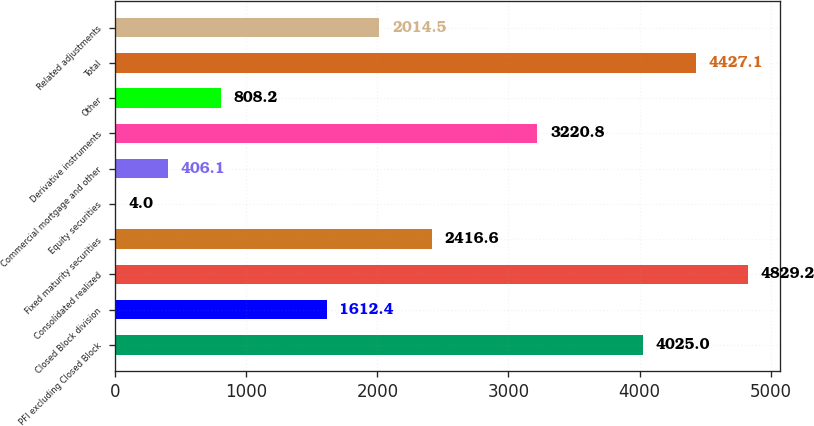Convert chart to OTSL. <chart><loc_0><loc_0><loc_500><loc_500><bar_chart><fcel>PFI excluding Closed Block<fcel>Closed Block division<fcel>Consolidated realized<fcel>Fixed maturity securities<fcel>Equity securities<fcel>Commercial mortgage and other<fcel>Derivative instruments<fcel>Other<fcel>Total<fcel>Related adjustments<nl><fcel>4025<fcel>1612.4<fcel>4829.2<fcel>2416.6<fcel>4<fcel>406.1<fcel>3220.8<fcel>808.2<fcel>4427.1<fcel>2014.5<nl></chart> 